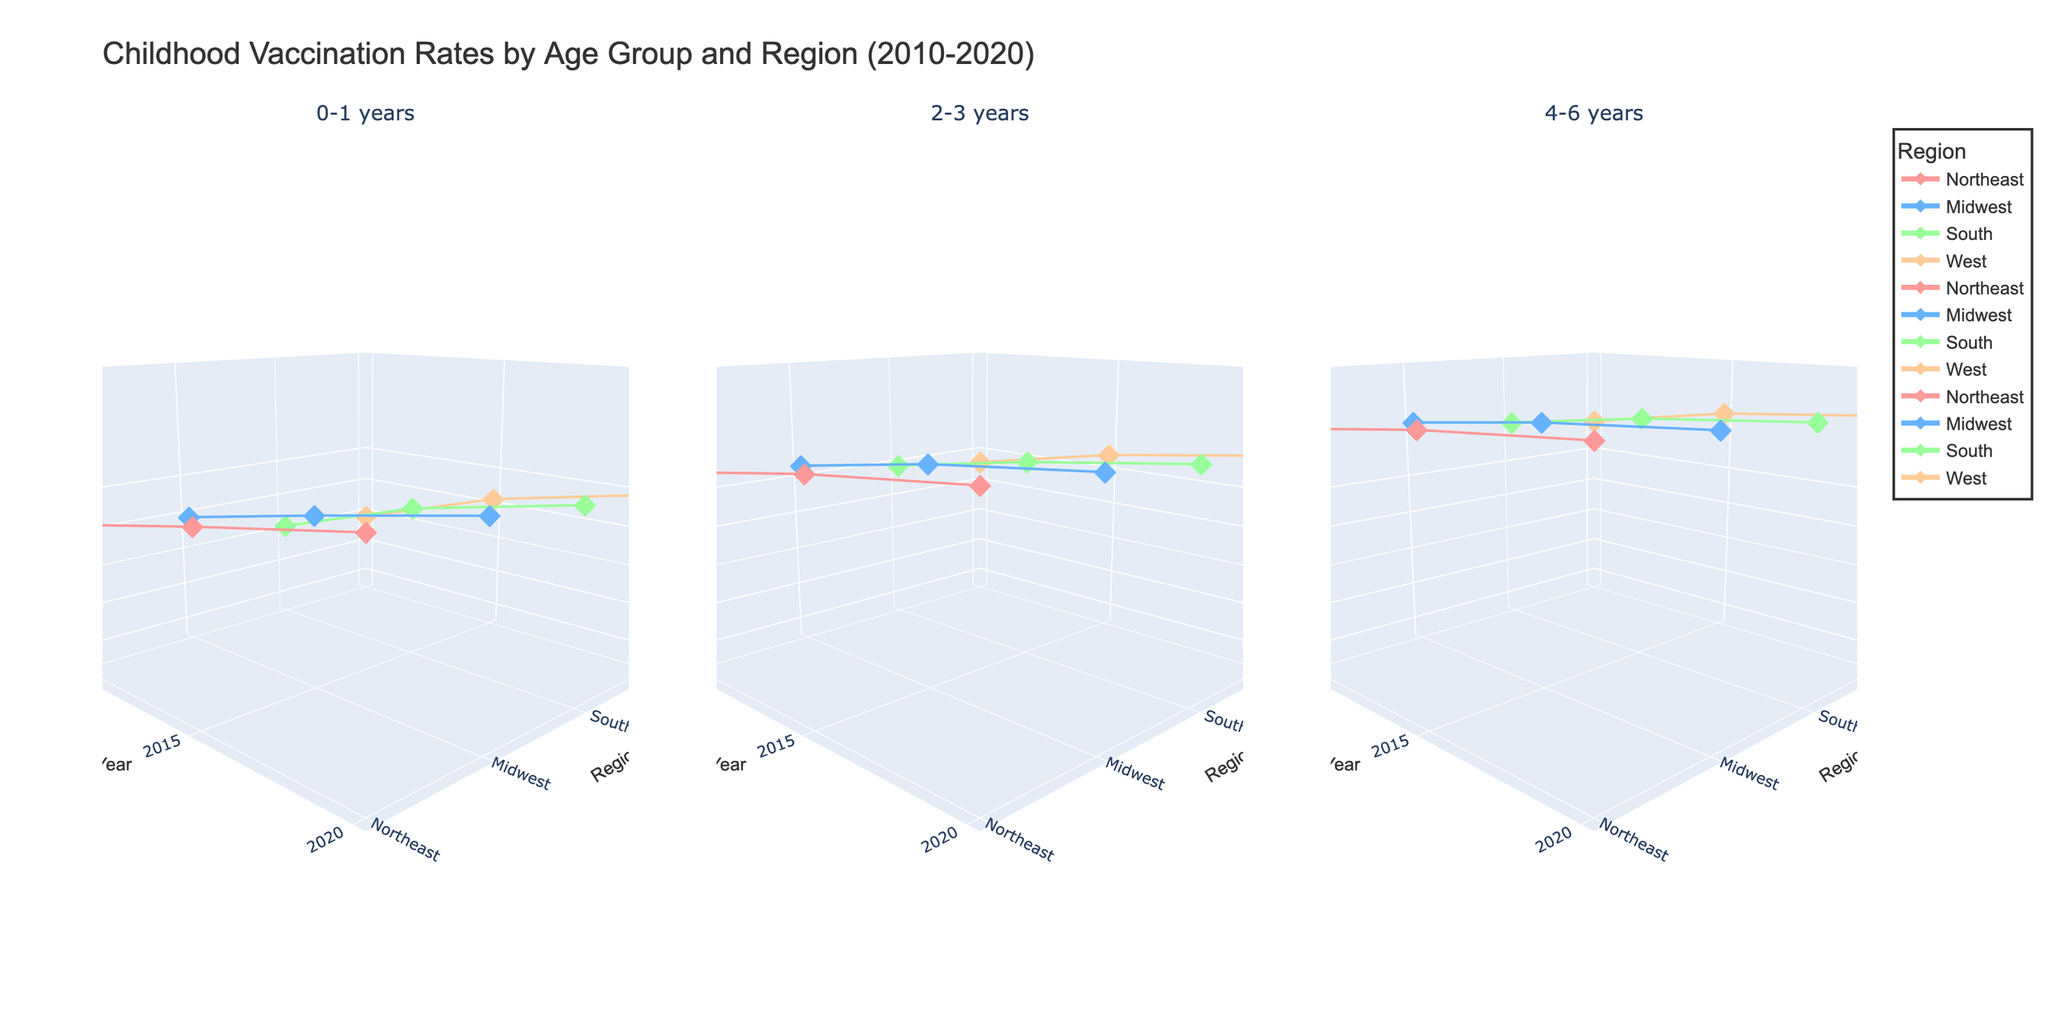What is the title of the plot? The title of the plot is typically displayed at the top and usually summarizes what the entire visualization is about.
Answer: Childhood Vaccination Rates by Age Group and Region (2010-2020) Which region has the highest vaccination rate for the 0-1 years age group in 2020? Look at the 0-1 years subplot, find the year 2020, and identify which region has the highest point on the vertical axis z (Vaccination Rate).
Answer: Northeast What is the range of years displayed on the x-axis in the plots? The x-axis represents the years, so observe its start (first tick) and end (last tick).
Answer: 2010 to 2020 Compare the vaccination rates of the Midwest and West regions for the 4-6 years age group in 2020. Which is higher? Locate the 4-6 years subplot, find the year 2020 on the x-axis, and compare the z-values (Vaccination Rate) for Midwest and West regions.
Answer: Midwest What overall trend can you observe for the 2-3 years age group vaccination rates from 2010 to 2020? Examine the 2-3 years subplot, and follow the z-values (Vaccination Rates) over the years (x-axis) for a general increasing or decreasing pattern.
Answer: Increasing Which age group had the most significant increase in vaccination rates in the Northeast between 2010 and 2020? For each age group subplot, look at the Northeast region's data points for 2010 and 2020 and compare the z-values to determine the greatest change.
Answer: 0-1 years Between 2015 and 2020, in the Midwest region, which age group showed the smallest increase in vaccination rates? Investigate each subplot for 2015 and 2020 in the Midwest region and find the age group with the minimum difference in vaccination rates (z-values).
Answer: 2-3 years What is the relative position of the South region's 4-6 years vaccination rate in 2015 compared to the other regions? Find the 4-6 years subplot, locate the year 2015, and compare the South region's z-value to other regions' z-values at the same year point.
Answer: Third highest What is the average vaccination rate for the West region across all years and age groups? Sum the vaccination rates for the West region across all points and divide by the total number of data points for the region.
Answer: 94.03 In general, which region tends to have the lowest vaccination rates across different age groups? Compare the lowest points across all three subplots among the regions. The region with the consistently lower z-values across multiple points is likely to have the lowest rates.
Answer: West 